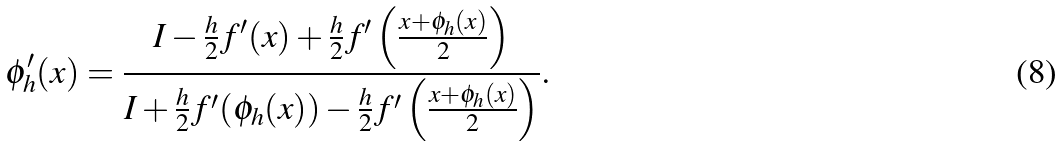Convert formula to latex. <formula><loc_0><loc_0><loc_500><loc_500>\phi _ { h } ^ { \prime } ( x ) = \frac { I - \frac { h } { 2 } f ^ { \prime } ( x ) + \frac { h } { 2 } f ^ { \prime } \left ( \frac { x + \phi _ { h } ( x ) } { 2 } \right ) } { I + \frac { h } { 2 } f ^ { \prime } ( \phi _ { h } ( x ) ) - \frac { h } { 2 } f ^ { \prime } \left ( \frac { x + \phi _ { h } ( x ) } { 2 } \right ) } .</formula> 